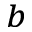<formula> <loc_0><loc_0><loc_500><loc_500>^ { b }</formula> 